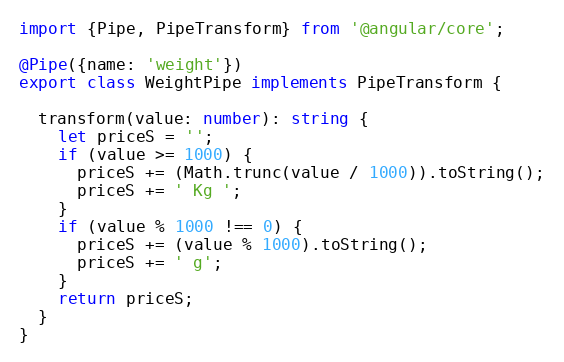Convert code to text. <code><loc_0><loc_0><loc_500><loc_500><_TypeScript_>import {Pipe, PipeTransform} from '@angular/core';

@Pipe({name: 'weight'})
export class WeightPipe implements PipeTransform {

  transform(value: number): string {
    let priceS = '';
    if (value >= 1000) {
      priceS += (Math.trunc(value / 1000)).toString();
      priceS += ' Kg ';
    }
    if (value % 1000 !== 0) {
      priceS += (value % 1000).toString();
      priceS += ' g';
    }
    return priceS;
  }
}
</code> 